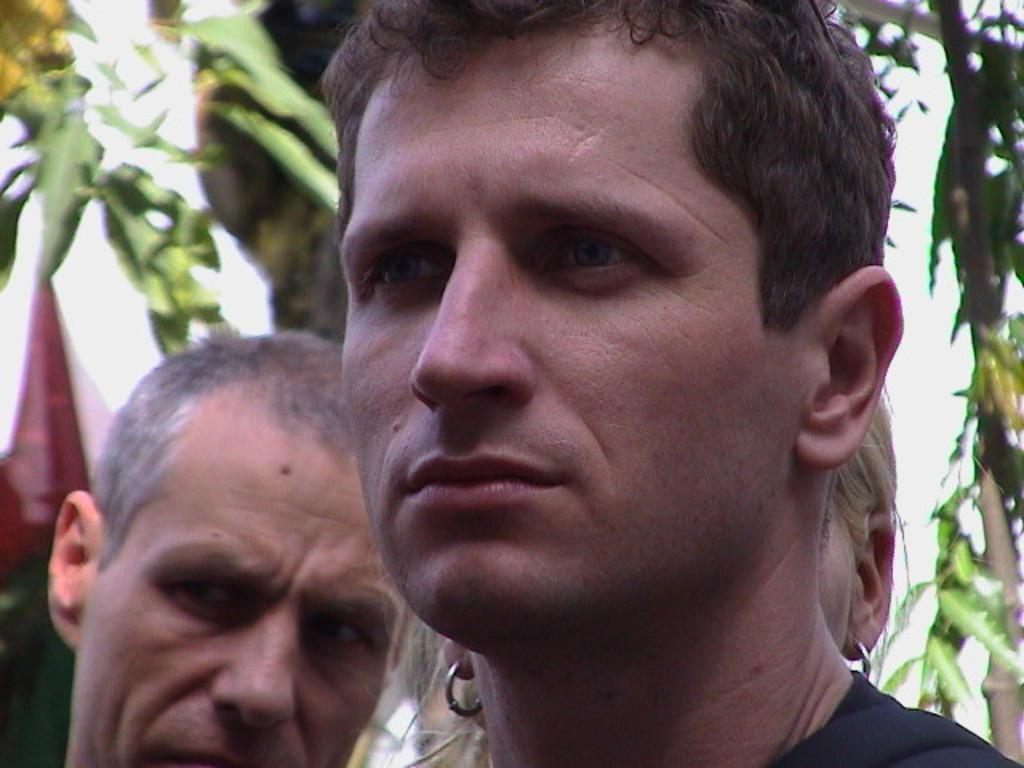Can you describe this image briefly? In this image we can see men. 